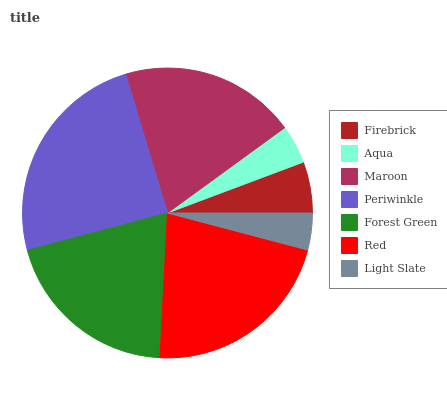Is Light Slate the minimum?
Answer yes or no. Yes. Is Periwinkle the maximum?
Answer yes or no. Yes. Is Aqua the minimum?
Answer yes or no. No. Is Aqua the maximum?
Answer yes or no. No. Is Firebrick greater than Aqua?
Answer yes or no. Yes. Is Aqua less than Firebrick?
Answer yes or no. Yes. Is Aqua greater than Firebrick?
Answer yes or no. No. Is Firebrick less than Aqua?
Answer yes or no. No. Is Maroon the high median?
Answer yes or no. Yes. Is Maroon the low median?
Answer yes or no. Yes. Is Periwinkle the high median?
Answer yes or no. No. Is Firebrick the low median?
Answer yes or no. No. 